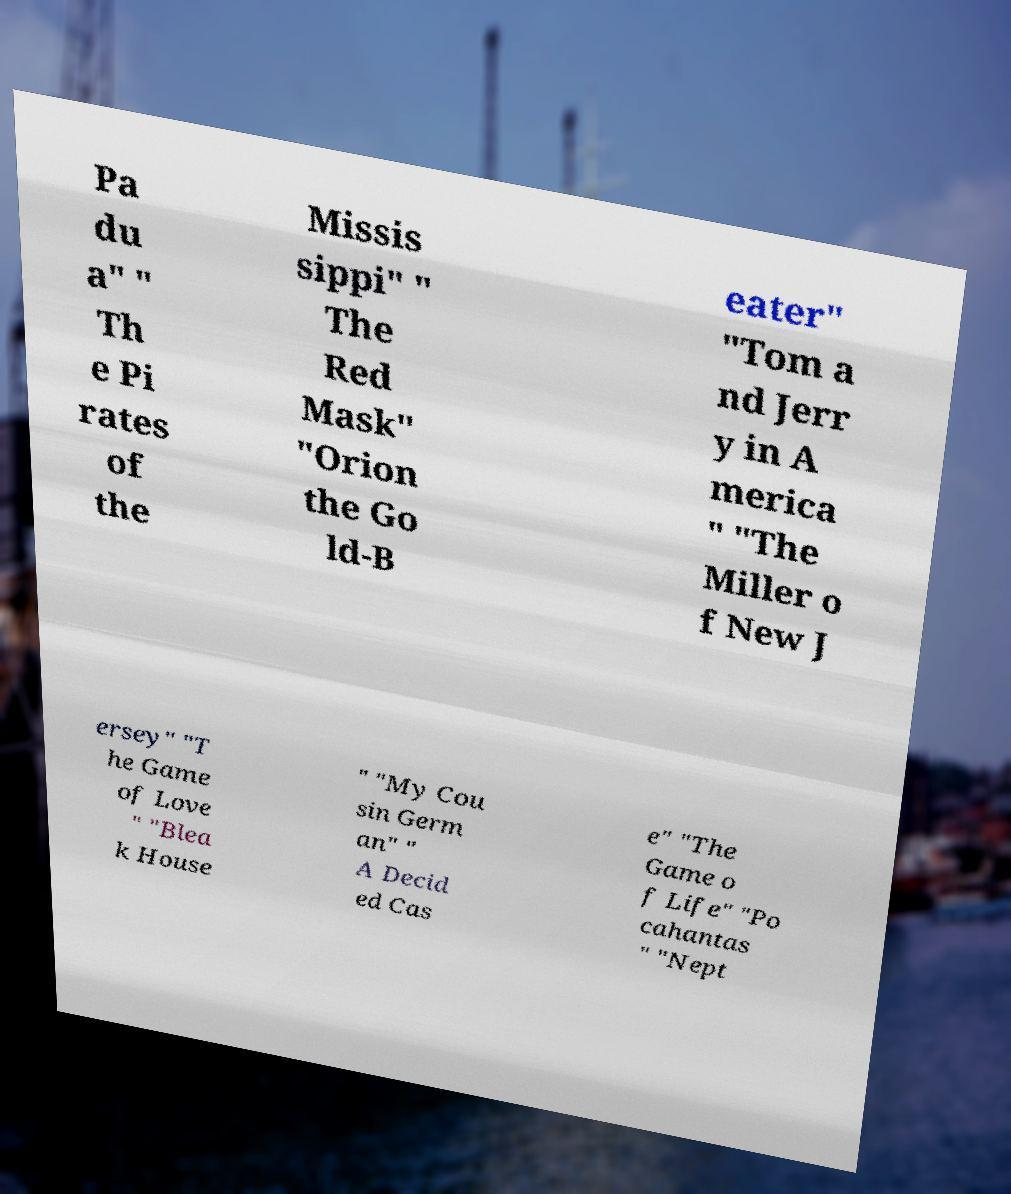Please read and relay the text visible in this image. What does it say? Pa du a" " Th e Pi rates of the Missis sippi" " The Red Mask" "Orion the Go ld-B eater" "Tom a nd Jerr y in A merica " "The Miller o f New J ersey" "T he Game of Love " "Blea k House " "My Cou sin Germ an" " A Decid ed Cas e" "The Game o f Life" "Po cahantas " "Nept 